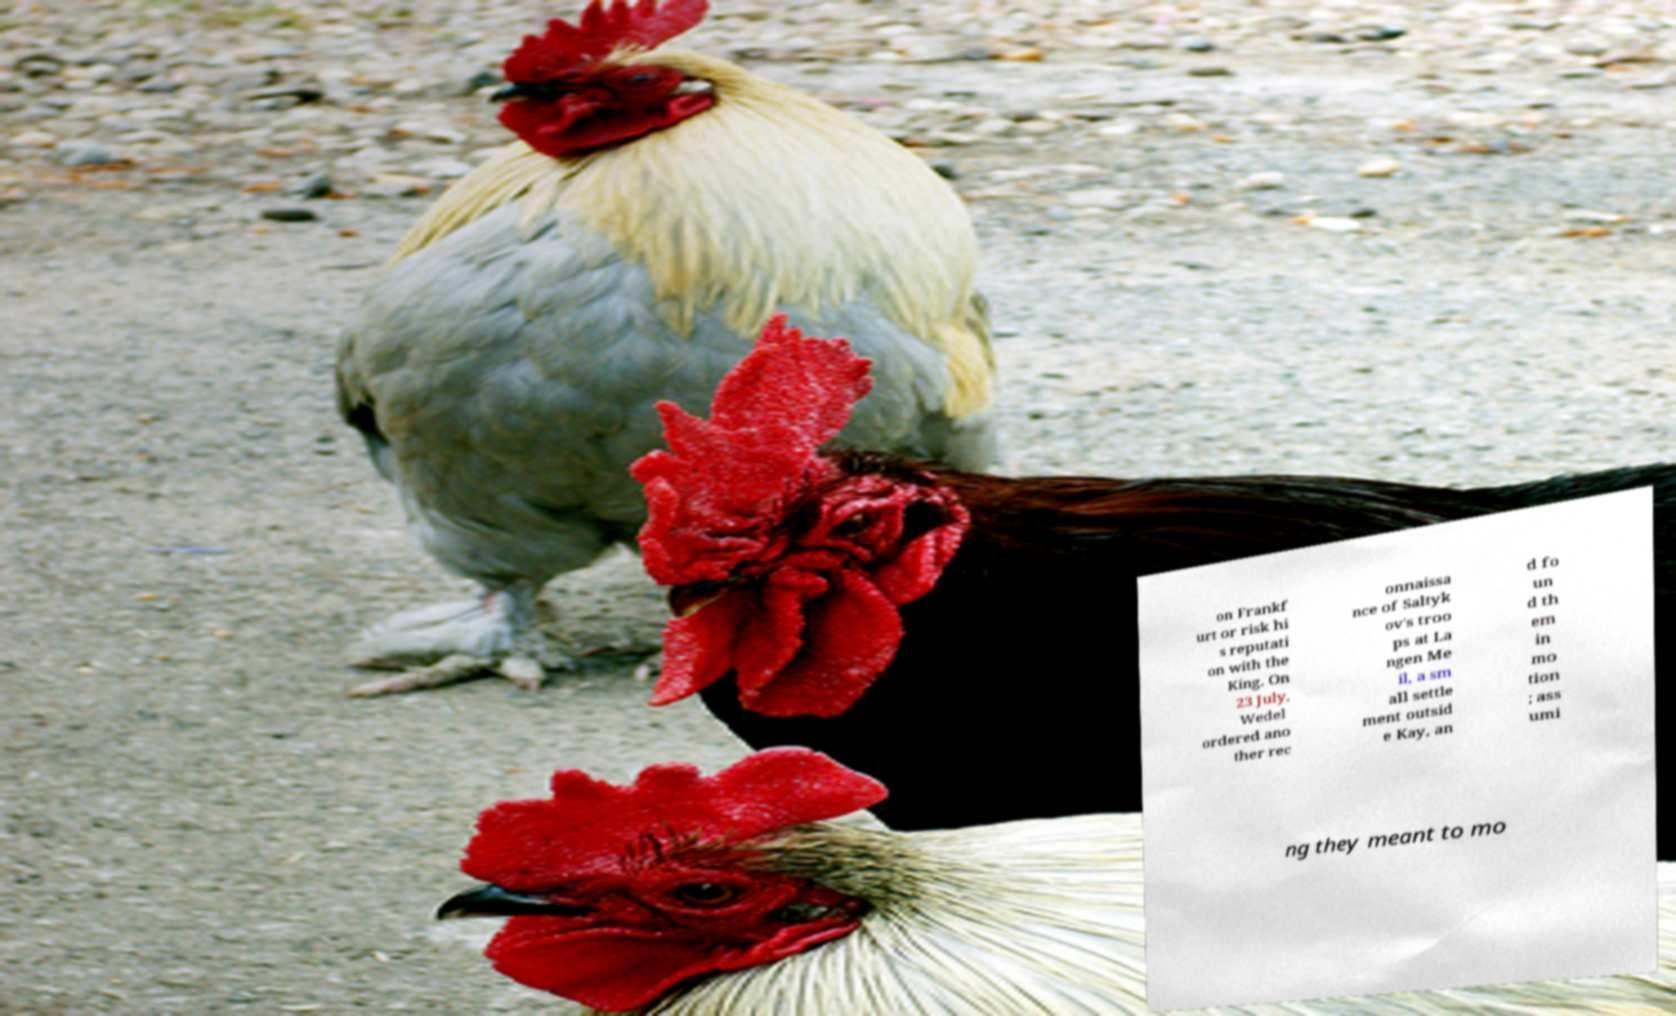Can you read and provide the text displayed in the image?This photo seems to have some interesting text. Can you extract and type it out for me? on Frankf urt or risk hi s reputati on with the King. On 23 July, Wedel ordered ano ther rec onnaissa nce of Saltyk ov's troo ps at La ngen Me il, a sm all settle ment outsid e Kay, an d fo un d th em in mo tion ; ass umi ng they meant to mo 